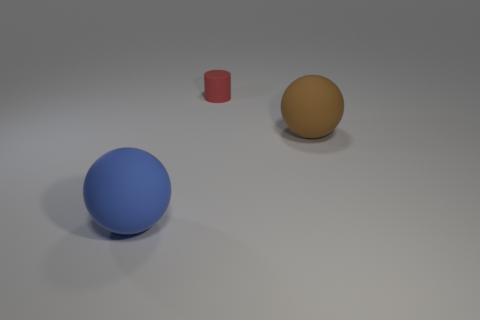Is there anything else that is the same size as the red cylinder?
Provide a succinct answer. No. Are there any other things that are the same color as the cylinder?
Your response must be concise. No. What number of things are either small brown things or brown rubber objects?
Offer a terse response. 1. There is a rubber ball on the right side of the big sphere that is left of the red matte object; what size is it?
Keep it short and to the point. Large. The blue ball has what size?
Offer a terse response. Large. What is the shape of the thing that is both in front of the matte cylinder and right of the blue rubber ball?
Provide a short and direct response. Sphere. What color is the other large matte object that is the same shape as the large brown rubber object?
Provide a short and direct response. Blue. How many objects are either balls that are to the left of the small cylinder or matte objects that are to the right of the large blue rubber object?
Your answer should be very brief. 3. What is the shape of the large blue rubber object?
Your answer should be compact. Sphere. What number of small cylinders are made of the same material as the tiny red thing?
Your answer should be compact. 0. 